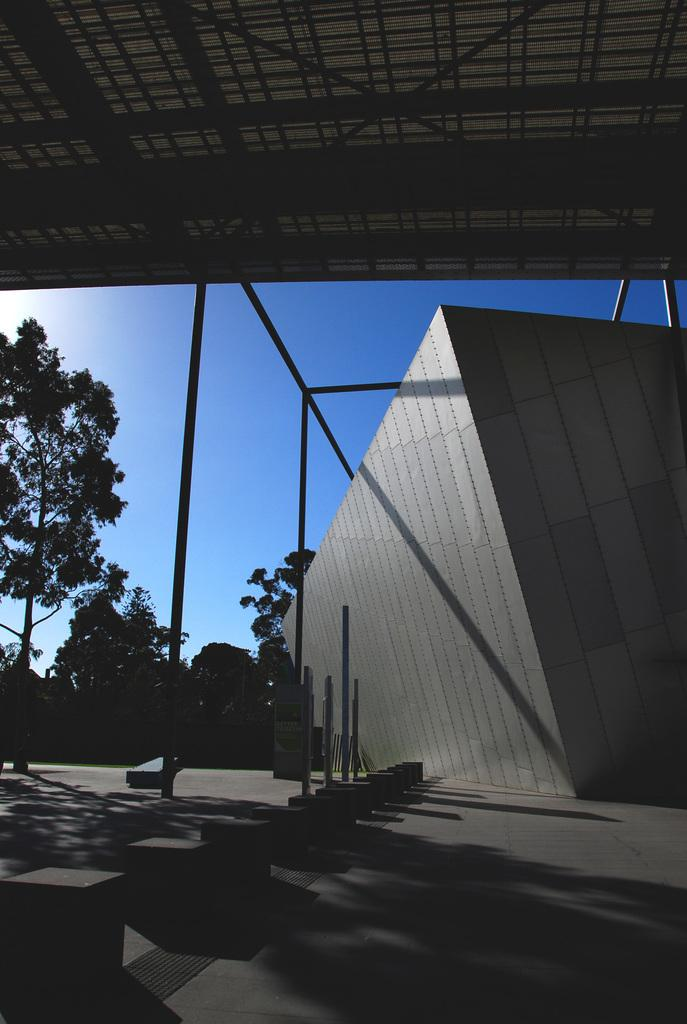What type of structures can be seen in the image? There are buildings in the image. What else can be found on the ground in the image? There are roads and trees in the image. What is visible in the background of the image? The sky is visible in the image. Can you describe any additional details about the image? Shadows are present in the image, and stones are visible in the middle of the image. What type of mint is growing on the cup in the image? There is no cup or mint present in the image. 